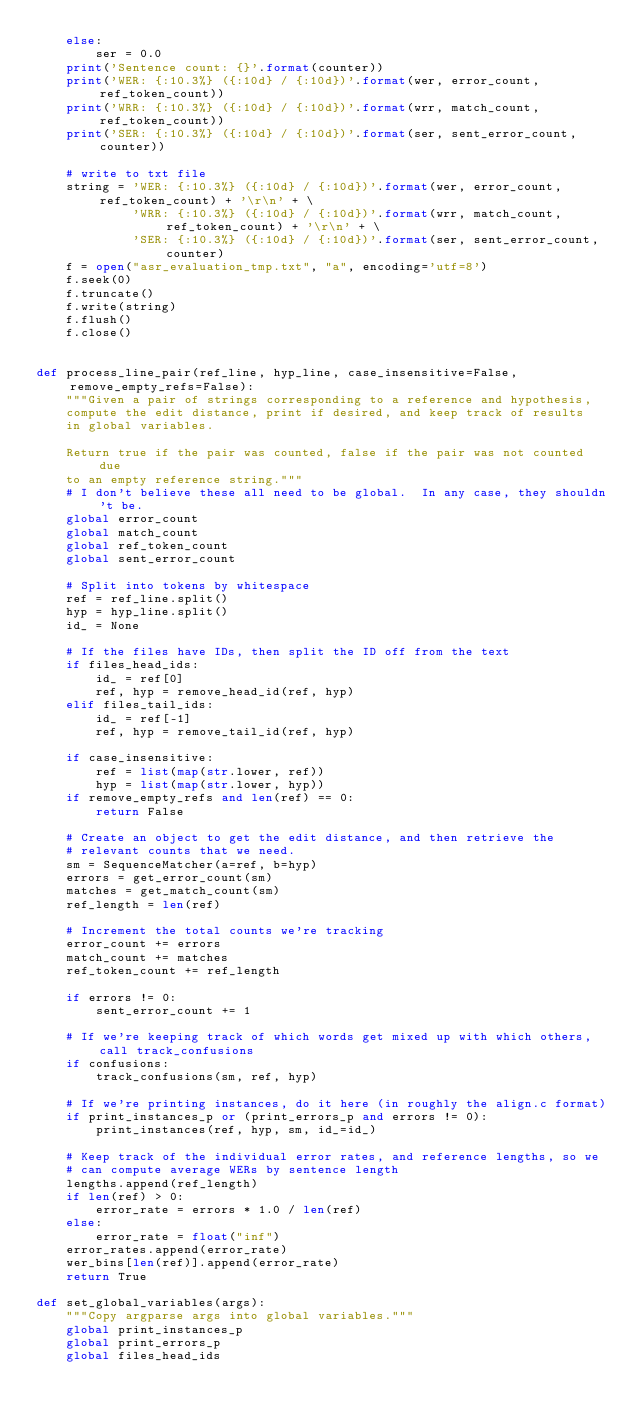Convert code to text. <code><loc_0><loc_0><loc_500><loc_500><_Python_>    else:
        ser = 0.0
    print('Sentence count: {}'.format(counter))
    print('WER: {:10.3%} ({:10d} / {:10d})'.format(wer, error_count, ref_token_count))
    print('WRR: {:10.3%} ({:10d} / {:10d})'.format(wrr, match_count, ref_token_count))
    print('SER: {:10.3%} ({:10d} / {:10d})'.format(ser, sent_error_count, counter))

    # write to txt file
    string = 'WER: {:10.3%} ({:10d} / {:10d})'.format(wer, error_count, ref_token_count) + '\r\n' + \
             'WRR: {:10.3%} ({:10d} / {:10d})'.format(wrr, match_count, ref_token_count) + '\r\n' + \
             'SER: {:10.3%} ({:10d} / {:10d})'.format(ser, sent_error_count, counter)
    f = open("asr_evaluation_tmp.txt", "a", encoding='utf=8')
    f.seek(0)
    f.truncate()
    f.write(string)
    f.flush()
    f.close()


def process_line_pair(ref_line, hyp_line, case_insensitive=False, remove_empty_refs=False):
    """Given a pair of strings corresponding to a reference and hypothesis,
    compute the edit distance, print if desired, and keep track of results
    in global variables.

    Return true if the pair was counted, false if the pair was not counted due
    to an empty reference string."""
    # I don't believe these all need to be global.  In any case, they shouldn't be.
    global error_count
    global match_count
    global ref_token_count
    global sent_error_count

    # Split into tokens by whitespace
    ref = ref_line.split()
    hyp = hyp_line.split()
    id_ = None

    # If the files have IDs, then split the ID off from the text
    if files_head_ids:
        id_ = ref[0]
        ref, hyp = remove_head_id(ref, hyp)
    elif files_tail_ids:
        id_ = ref[-1]
        ref, hyp = remove_tail_id(ref, hyp)

    if case_insensitive:
        ref = list(map(str.lower, ref))
        hyp = list(map(str.lower, hyp))
    if remove_empty_refs and len(ref) == 0:
        return False

    # Create an object to get the edit distance, and then retrieve the
    # relevant counts that we need.
    sm = SequenceMatcher(a=ref, b=hyp)
    errors = get_error_count(sm)
    matches = get_match_count(sm)
    ref_length = len(ref)

    # Increment the total counts we're tracking
    error_count += errors
    match_count += matches
    ref_token_count += ref_length

    if errors != 0:
        sent_error_count += 1

    # If we're keeping track of which words get mixed up with which others, call track_confusions
    if confusions:
        track_confusions(sm, ref, hyp)

    # If we're printing instances, do it here (in roughly the align.c format)
    if print_instances_p or (print_errors_p and errors != 0):
        print_instances(ref, hyp, sm, id_=id_)

    # Keep track of the individual error rates, and reference lengths, so we
    # can compute average WERs by sentence length
    lengths.append(ref_length)
    if len(ref) > 0:
        error_rate = errors * 1.0 / len(ref)
    else:
        error_rate = float("inf")
    error_rates.append(error_rate)
    wer_bins[len(ref)].append(error_rate)
    return True

def set_global_variables(args):
    """Copy argparse args into global variables."""
    global print_instances_p
    global print_errors_p
    global files_head_ids</code> 